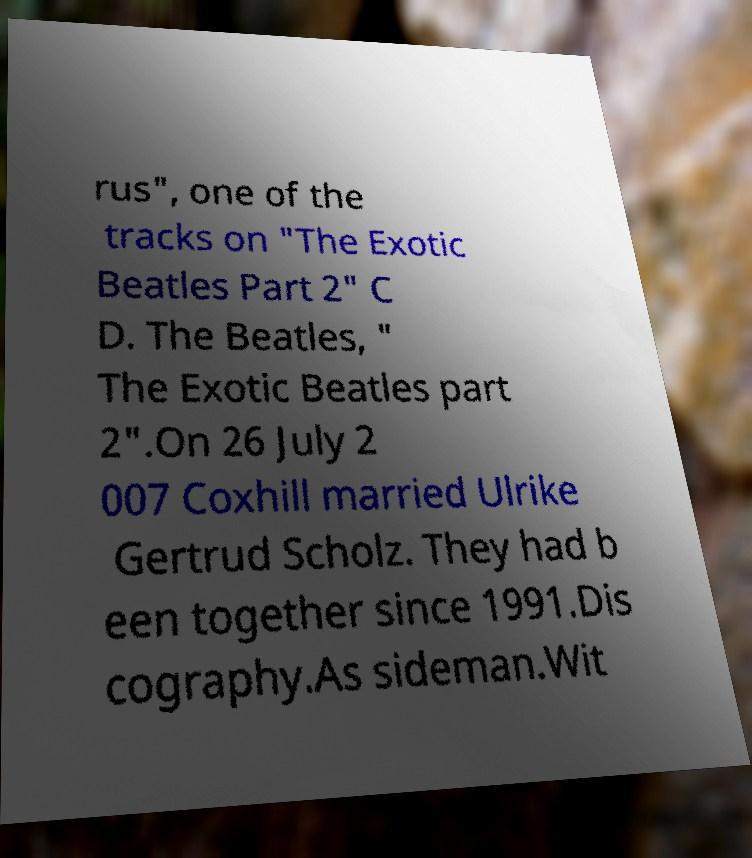Please identify and transcribe the text found in this image. rus", one of the tracks on "The Exotic Beatles Part 2" C D. The Beatles, " The Exotic Beatles part 2".On 26 July 2 007 Coxhill married Ulrike Gertrud Scholz. They had b een together since 1991.Dis cography.As sideman.Wit 